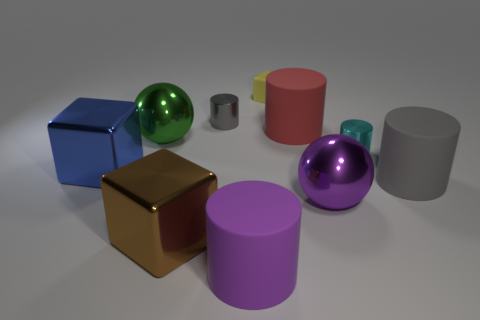What number of small gray metallic cylinders are left of the large red thing?
Provide a short and direct response. 1. Is the number of tiny cyan cylinders in front of the big brown shiny object the same as the number of metal cylinders?
Offer a very short reply. No. Is the material of the red cylinder the same as the big purple cylinder?
Provide a short and direct response. Yes. How big is the block that is right of the big green metallic thing and in front of the tiny gray thing?
Offer a very short reply. Large. How many gray shiny cylinders have the same size as the blue metallic thing?
Offer a very short reply. 0. How big is the gray thing in front of the tiny metallic object that is on the right side of the purple rubber cylinder?
Keep it short and to the point. Large. Does the object that is left of the green shiny object have the same shape as the big red matte thing that is right of the small yellow cube?
Provide a succinct answer. No. There is a cylinder that is to the left of the tiny block and behind the large brown cube; what is its color?
Give a very brief answer. Gray. Is there another small object that has the same color as the tiny rubber object?
Make the answer very short. No. What is the color of the big object that is in front of the large brown metal object?
Keep it short and to the point. Purple. 